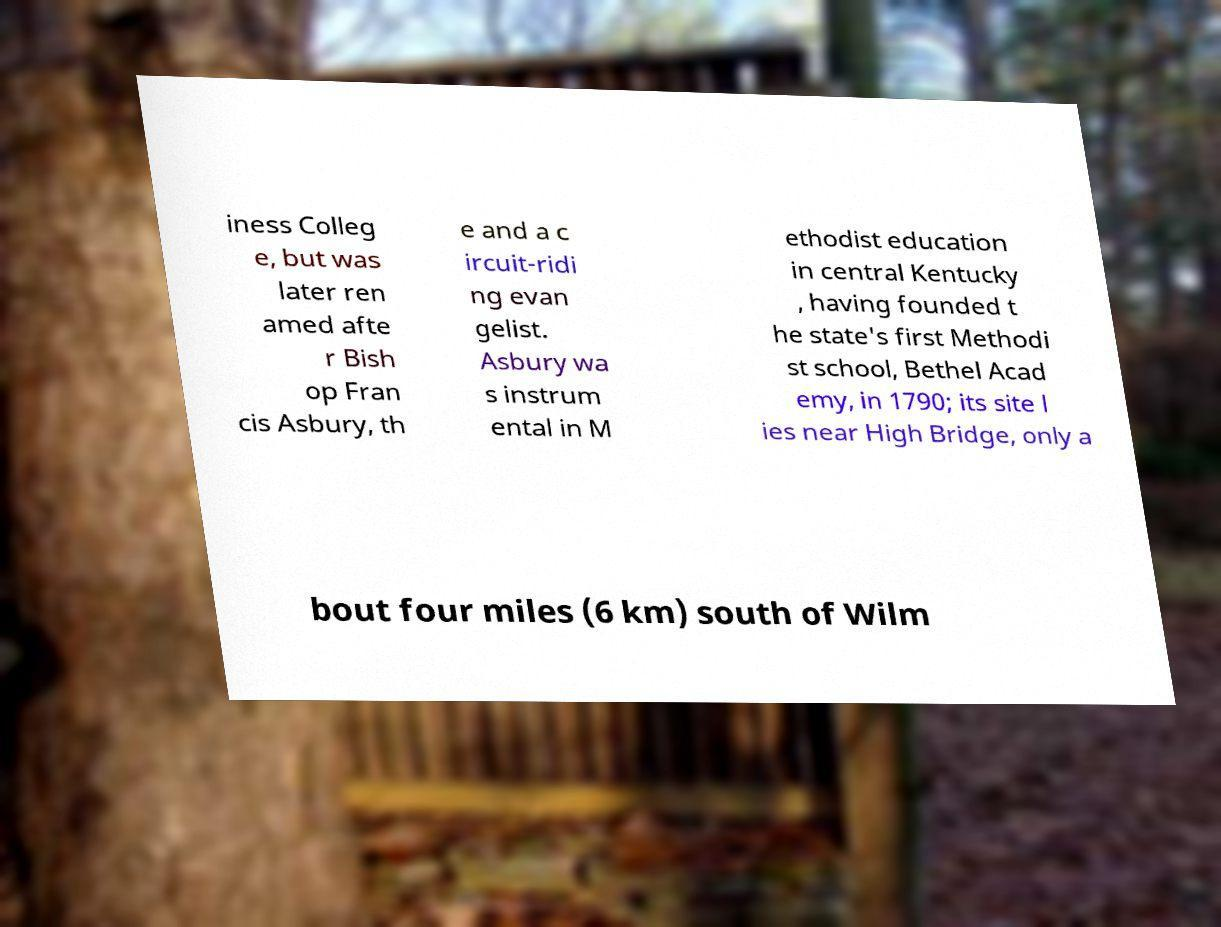For documentation purposes, I need the text within this image transcribed. Could you provide that? iness Colleg e, but was later ren amed afte r Bish op Fran cis Asbury, th e and a c ircuit-ridi ng evan gelist. Asbury wa s instrum ental in M ethodist education in central Kentucky , having founded t he state's first Methodi st school, Bethel Acad emy, in 1790; its site l ies near High Bridge, only a bout four miles (6 km) south of Wilm 